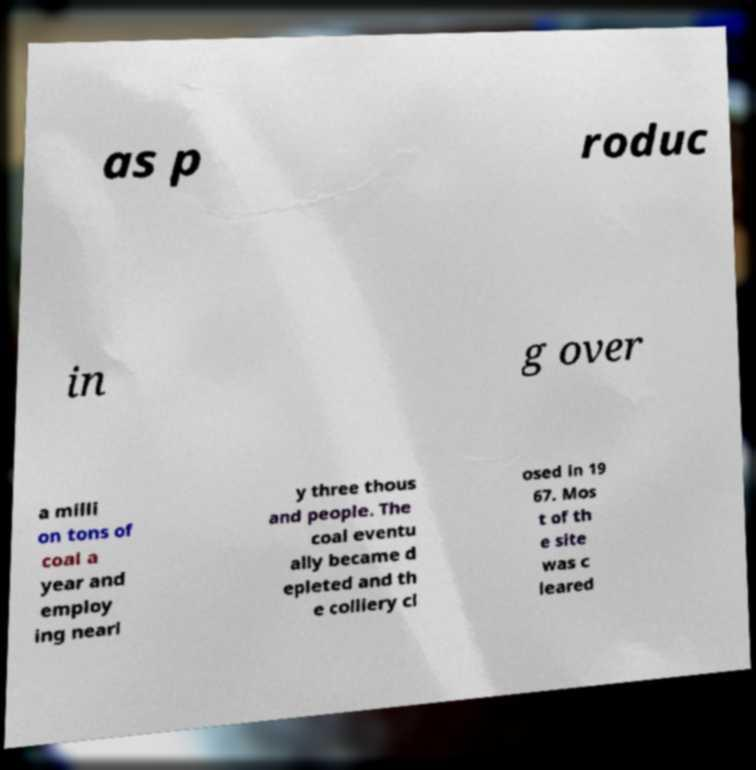For documentation purposes, I need the text within this image transcribed. Could you provide that? as p roduc in g over a milli on tons of coal a year and employ ing nearl y three thous and people. The coal eventu ally became d epleted and th e colliery cl osed in 19 67. Mos t of th e site was c leared 